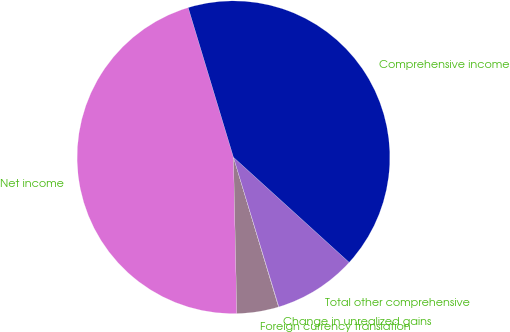Convert chart. <chart><loc_0><loc_0><loc_500><loc_500><pie_chart><fcel>Net income<fcel>Foreign currency translation<fcel>Change in unrealized gains<fcel>Total other comprehensive<fcel>Comprehensive income<nl><fcel>45.67%<fcel>4.31%<fcel>0.04%<fcel>8.57%<fcel>41.41%<nl></chart> 